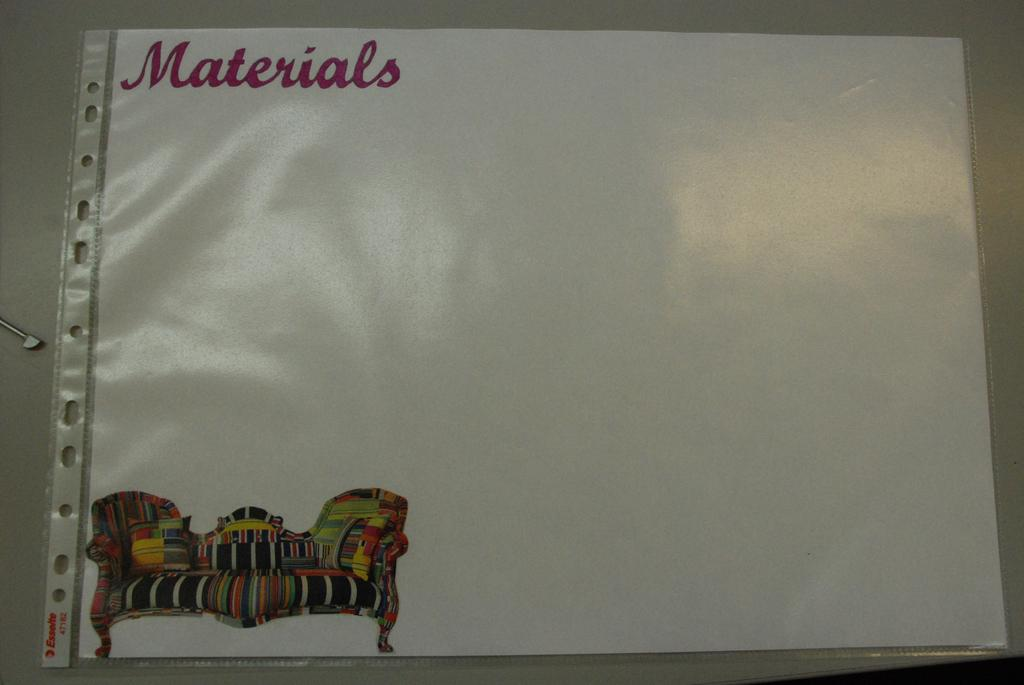<image>
Provide a brief description of the given image. A picture of a colorful couch is on a sheet of paper titled Materials. 